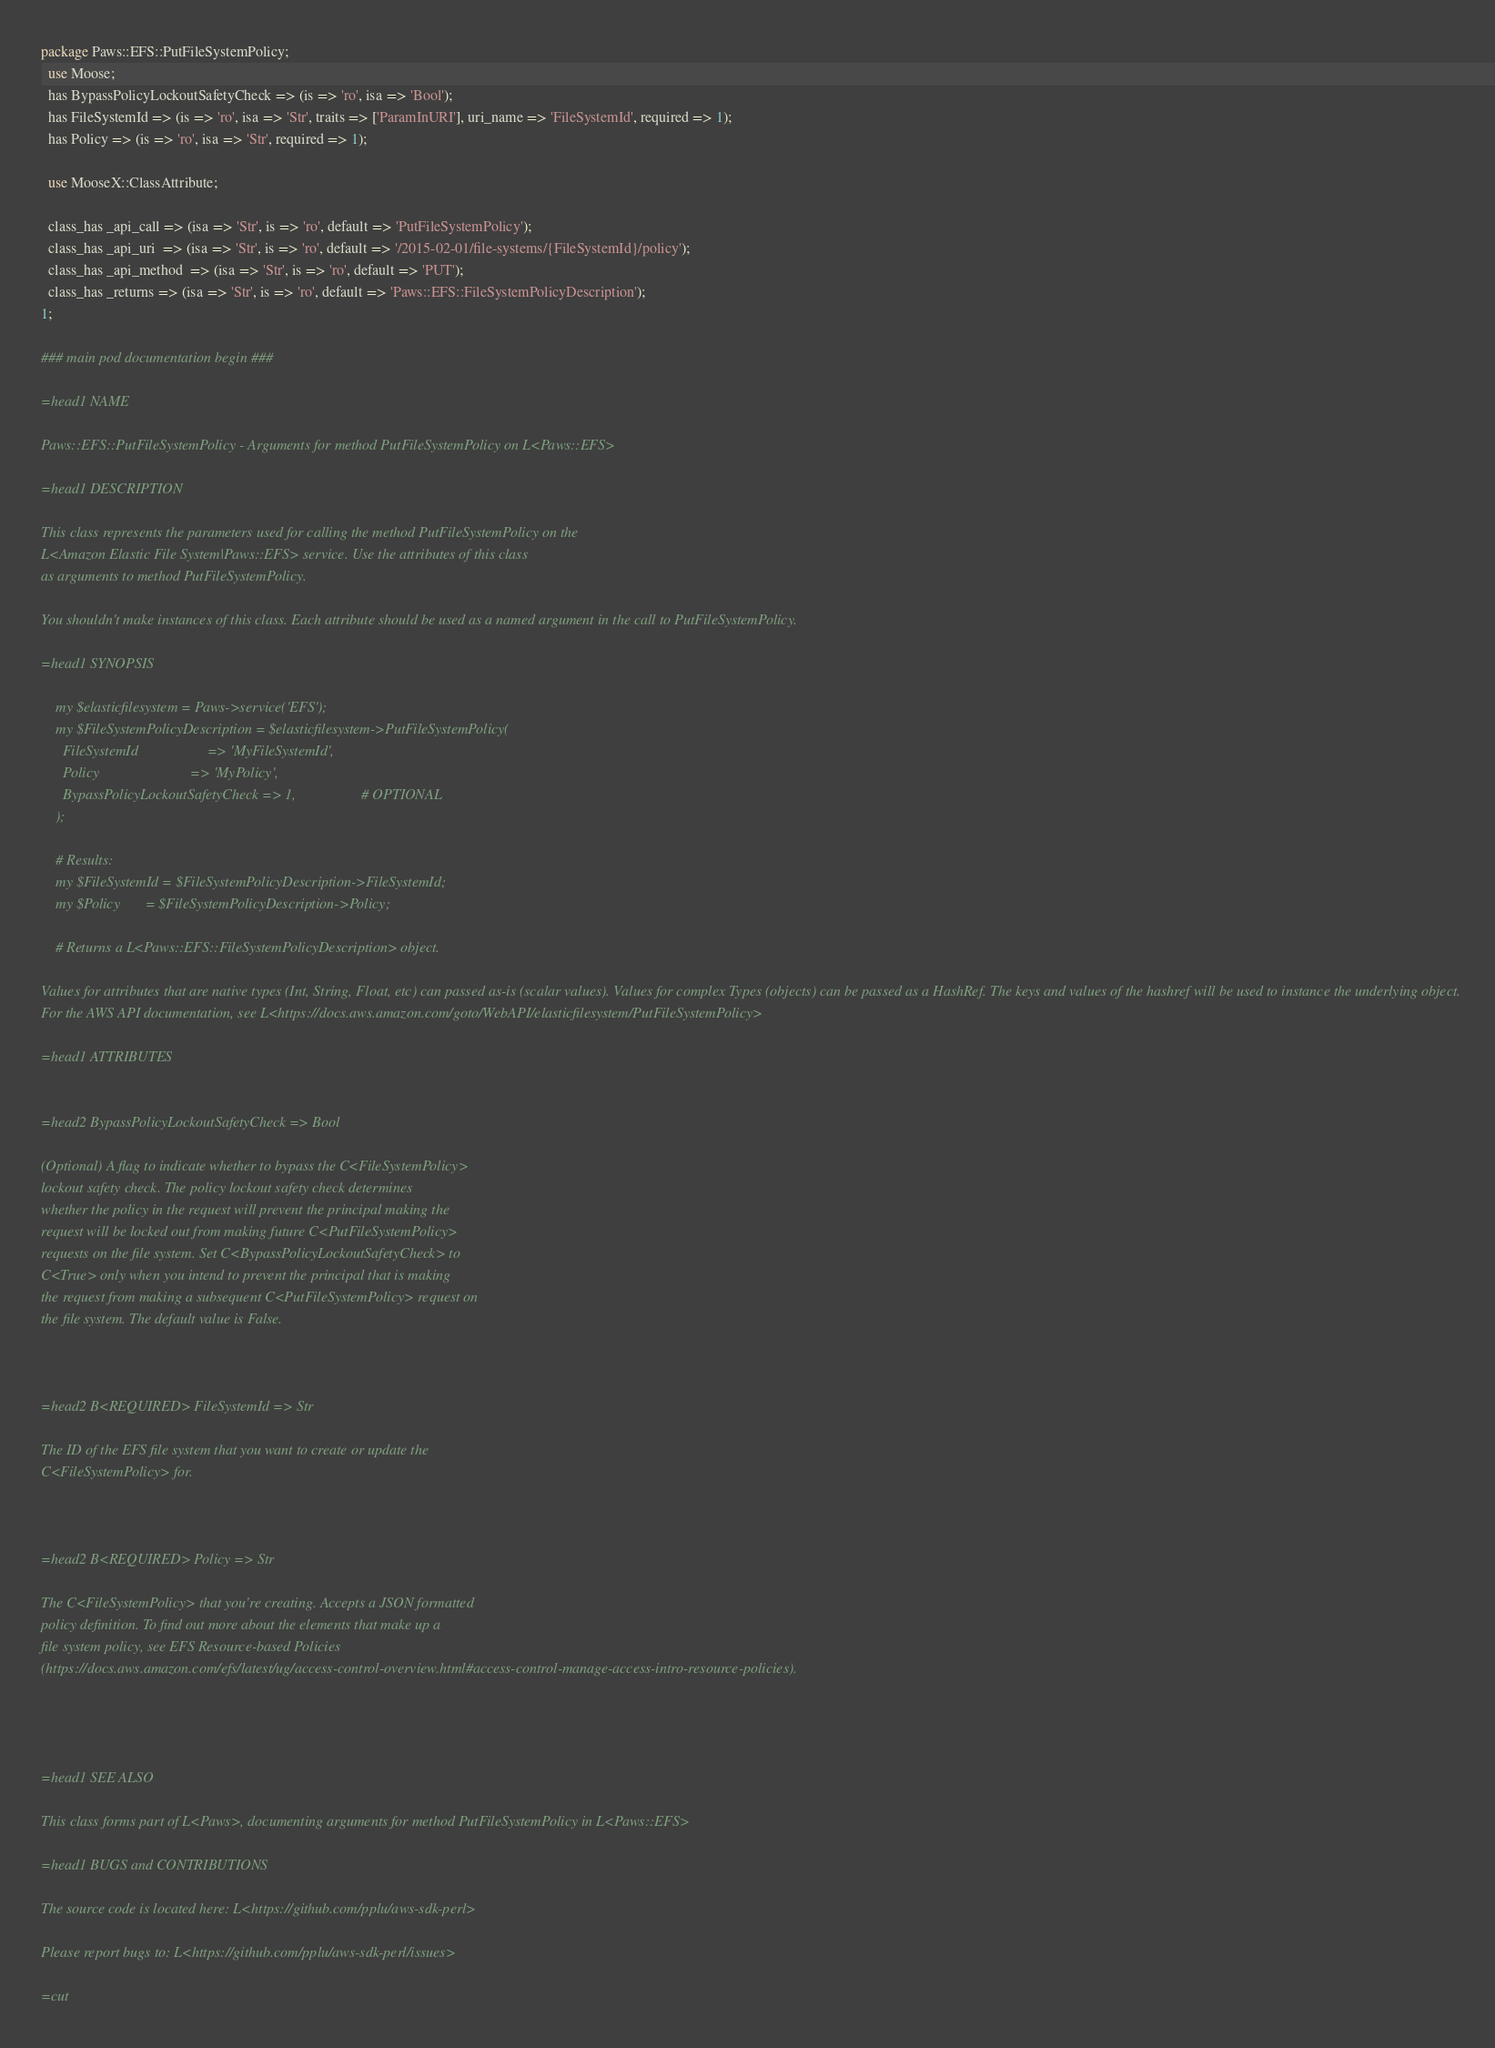<code> <loc_0><loc_0><loc_500><loc_500><_Perl_>
package Paws::EFS::PutFileSystemPolicy;
  use Moose;
  has BypassPolicyLockoutSafetyCheck => (is => 'ro', isa => 'Bool');
  has FileSystemId => (is => 'ro', isa => 'Str', traits => ['ParamInURI'], uri_name => 'FileSystemId', required => 1);
  has Policy => (is => 'ro', isa => 'Str', required => 1);

  use MooseX::ClassAttribute;

  class_has _api_call => (isa => 'Str', is => 'ro', default => 'PutFileSystemPolicy');
  class_has _api_uri  => (isa => 'Str', is => 'ro', default => '/2015-02-01/file-systems/{FileSystemId}/policy');
  class_has _api_method  => (isa => 'Str', is => 'ro', default => 'PUT');
  class_has _returns => (isa => 'Str', is => 'ro', default => 'Paws::EFS::FileSystemPolicyDescription');
1;

### main pod documentation begin ###

=head1 NAME

Paws::EFS::PutFileSystemPolicy - Arguments for method PutFileSystemPolicy on L<Paws::EFS>

=head1 DESCRIPTION

This class represents the parameters used for calling the method PutFileSystemPolicy on the
L<Amazon Elastic File System|Paws::EFS> service. Use the attributes of this class
as arguments to method PutFileSystemPolicy.

You shouldn't make instances of this class. Each attribute should be used as a named argument in the call to PutFileSystemPolicy.

=head1 SYNOPSIS

    my $elasticfilesystem = Paws->service('EFS');
    my $FileSystemPolicyDescription = $elasticfilesystem->PutFileSystemPolicy(
      FileSystemId                   => 'MyFileSystemId',
      Policy                         => 'MyPolicy',
      BypassPolicyLockoutSafetyCheck => 1,                  # OPTIONAL
    );

    # Results:
    my $FileSystemId = $FileSystemPolicyDescription->FileSystemId;
    my $Policy       = $FileSystemPolicyDescription->Policy;

    # Returns a L<Paws::EFS::FileSystemPolicyDescription> object.

Values for attributes that are native types (Int, String, Float, etc) can passed as-is (scalar values). Values for complex Types (objects) can be passed as a HashRef. The keys and values of the hashref will be used to instance the underlying object.
For the AWS API documentation, see L<https://docs.aws.amazon.com/goto/WebAPI/elasticfilesystem/PutFileSystemPolicy>

=head1 ATTRIBUTES


=head2 BypassPolicyLockoutSafetyCheck => Bool

(Optional) A flag to indicate whether to bypass the C<FileSystemPolicy>
lockout safety check. The policy lockout safety check determines
whether the policy in the request will prevent the principal making the
request will be locked out from making future C<PutFileSystemPolicy>
requests on the file system. Set C<BypassPolicyLockoutSafetyCheck> to
C<True> only when you intend to prevent the principal that is making
the request from making a subsequent C<PutFileSystemPolicy> request on
the file system. The default value is False.



=head2 B<REQUIRED> FileSystemId => Str

The ID of the EFS file system that you want to create or update the
C<FileSystemPolicy> for.



=head2 B<REQUIRED> Policy => Str

The C<FileSystemPolicy> that you're creating. Accepts a JSON formatted
policy definition. To find out more about the elements that make up a
file system policy, see EFS Resource-based Policies
(https://docs.aws.amazon.com/efs/latest/ug/access-control-overview.html#access-control-manage-access-intro-resource-policies).




=head1 SEE ALSO

This class forms part of L<Paws>, documenting arguments for method PutFileSystemPolicy in L<Paws::EFS>

=head1 BUGS and CONTRIBUTIONS

The source code is located here: L<https://github.com/pplu/aws-sdk-perl>

Please report bugs to: L<https://github.com/pplu/aws-sdk-perl/issues>

=cut

</code> 